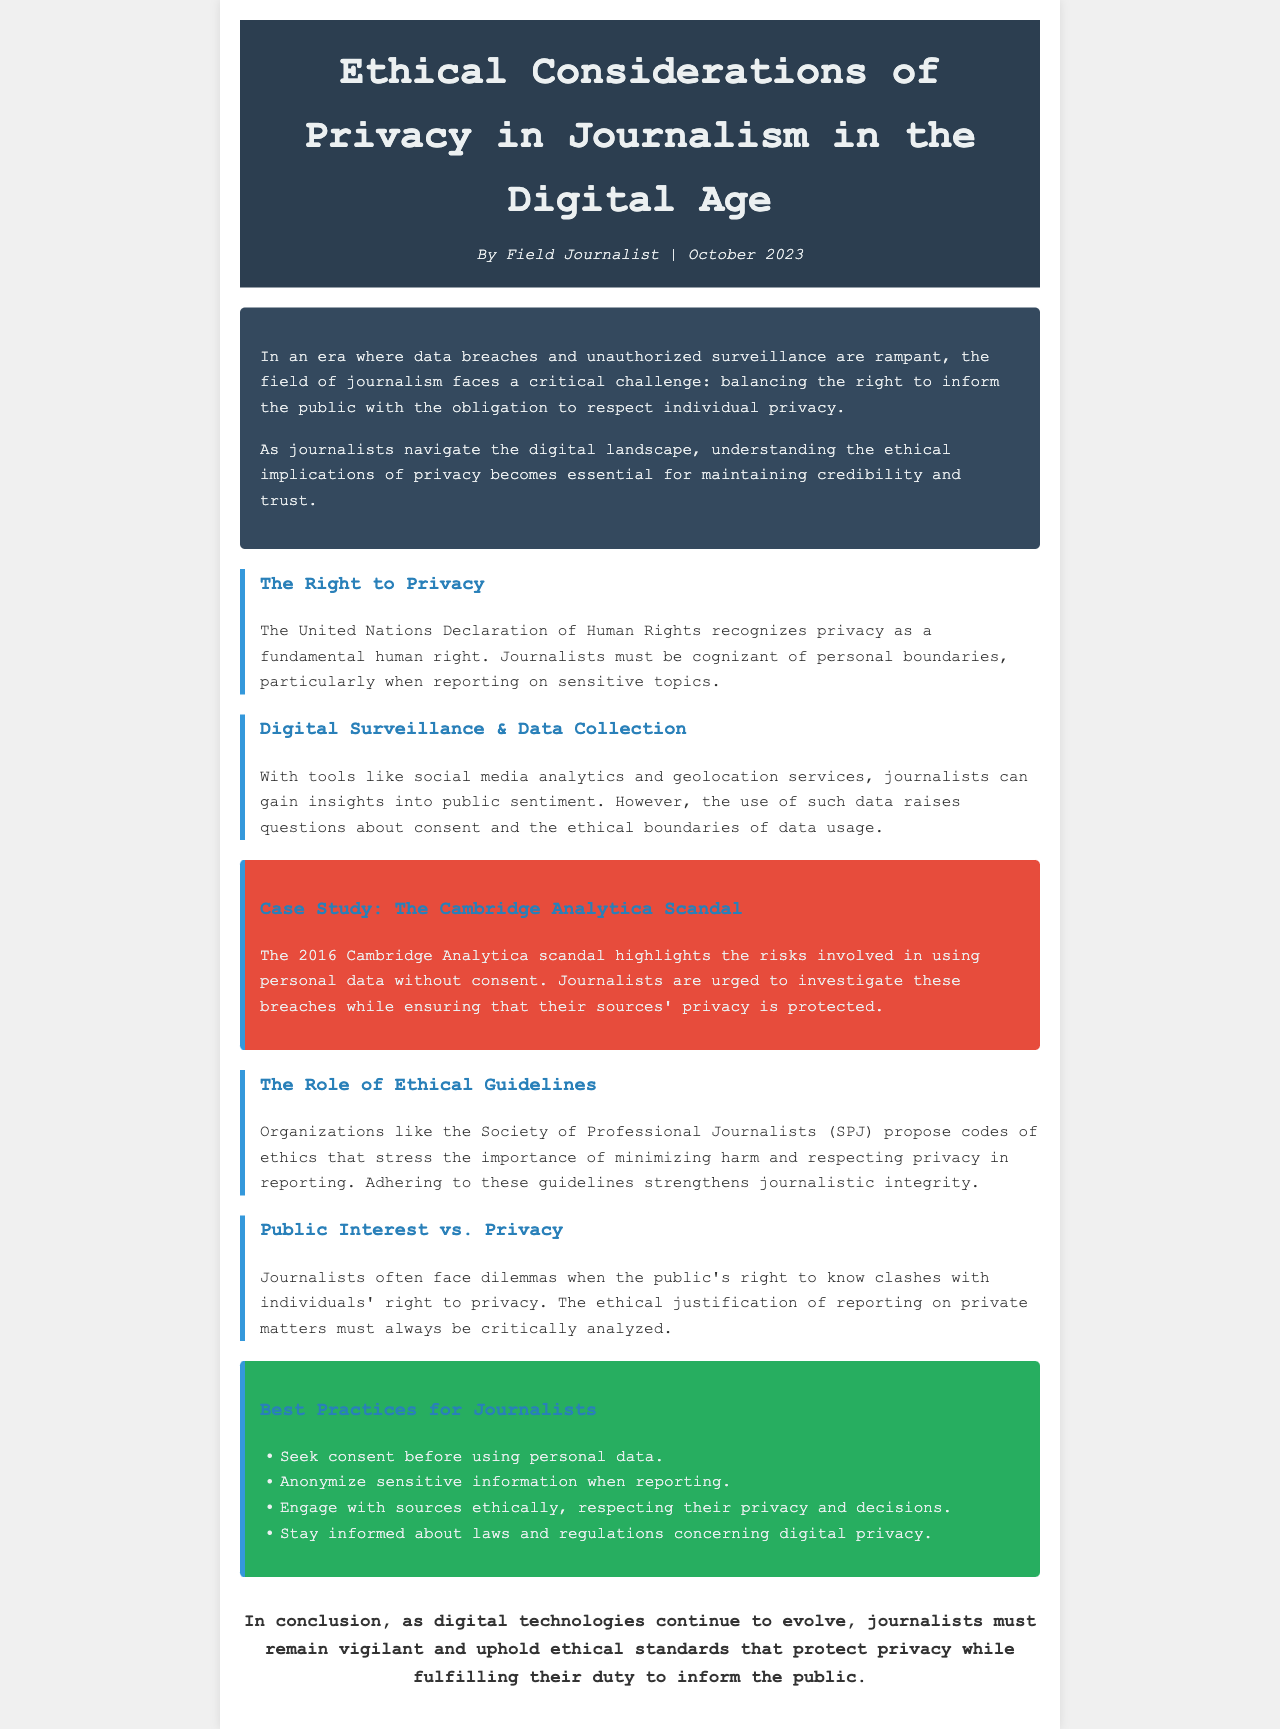What is the title of the document? The title of the document is stated in the header section.
Answer: Ethical Considerations of Privacy in Journalism in the Digital Age Who is the author? The author is identified at the top of the document.
Answer: Field Journalist What year was this document published? The publication date is mentioned alongside the author's name.
Answer: October 2023 What is recognized as a fundamental human right? This information can be found in the section discussing The Right to Privacy.
Answer: Privacy What case study is mentioned in the document? The case study is referenced under a specific key point.
Answer: The Cambridge Analytica Scandal What organization proposes ethical guidelines for journalists? This is mentioned in the segment about ethical guidelines.
Answer: Society of Professional Journalists (SPJ) What is a best practice for journalists regarding personal data? This is one of the recommended practices listed in the document.
Answer: Seek consent before using personal data What is the main ethical dilemma discussed in the document? This refers to a conflict highlighted in the section concerning Public Interest vs. Privacy.
Answer: Public's right to know vs. individuals' right to privacy How many best practices are listed in the document? This can be counted from the best practices section.
Answer: Four 